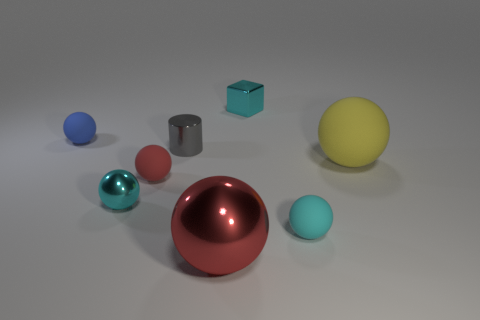There is a block that is the same color as the small metallic ball; what material is it?
Provide a succinct answer. Metal. How many metallic cubes are to the left of the red shiny object?
Your answer should be compact. 0. How many yellow objects are made of the same material as the blue ball?
Keep it short and to the point. 1. The big sphere that is made of the same material as the block is what color?
Make the answer very short. Red. There is a small blue sphere that is on the left side of the large red ball that is right of the cyan object that is to the left of the cylinder; what is it made of?
Give a very brief answer. Rubber. There is a cyan object to the right of the block; does it have the same size as the red shiny thing?
Ensure brevity in your answer.  No. What number of large things are gray shiny objects or blue matte things?
Offer a very short reply. 0. Is there a large metallic cube of the same color as the tiny metal ball?
Offer a very short reply. No. What is the shape of the gray thing that is the same size as the block?
Give a very brief answer. Cylinder. Is the color of the metallic ball that is to the left of the small gray cylinder the same as the tiny metallic cube?
Make the answer very short. Yes. 